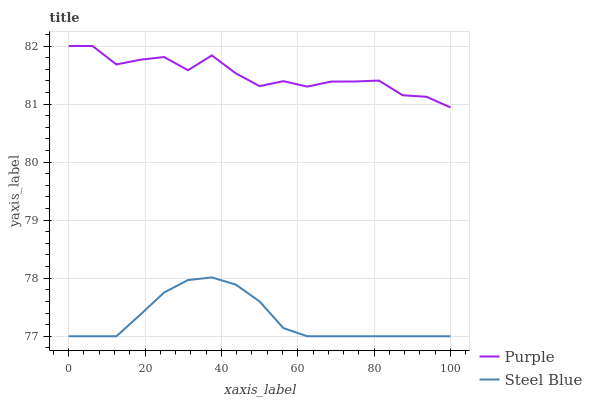Does Steel Blue have the minimum area under the curve?
Answer yes or no. Yes. Does Purple have the maximum area under the curve?
Answer yes or no. Yes. Does Steel Blue have the maximum area under the curve?
Answer yes or no. No. Is Steel Blue the smoothest?
Answer yes or no. Yes. Is Purple the roughest?
Answer yes or no. Yes. Is Steel Blue the roughest?
Answer yes or no. No. Does Purple have the highest value?
Answer yes or no. Yes. Does Steel Blue have the highest value?
Answer yes or no. No. Is Steel Blue less than Purple?
Answer yes or no. Yes. Is Purple greater than Steel Blue?
Answer yes or no. Yes. Does Steel Blue intersect Purple?
Answer yes or no. No. 